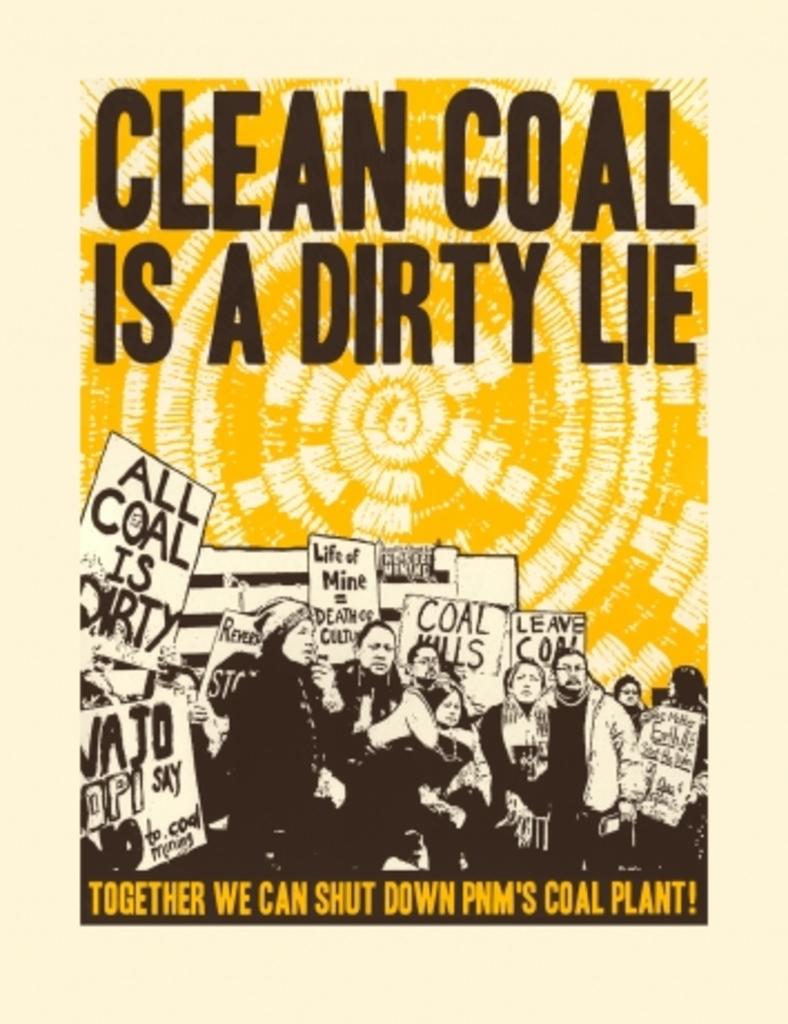What is a dirty lie?
Your answer should be compact. Clean coal. 